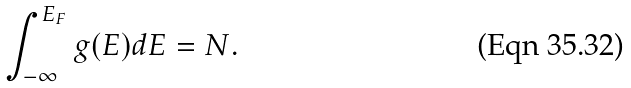Convert formula to latex. <formula><loc_0><loc_0><loc_500><loc_500>\int _ { - \infty } ^ { E _ { F } } g ( E ) d E = N .</formula> 